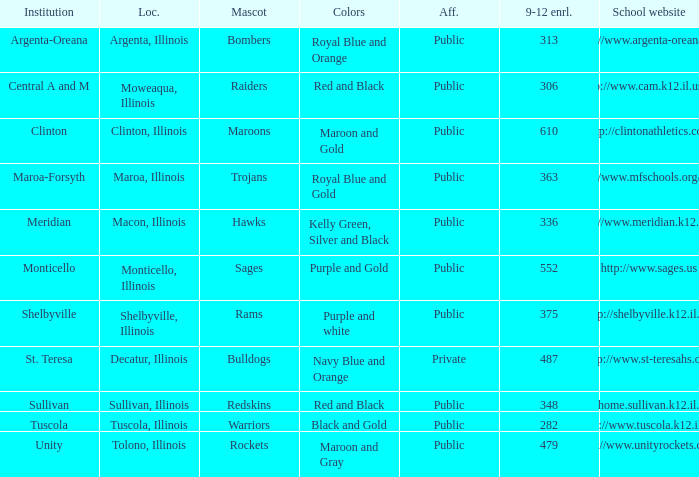How many different combinations of team colors are there in all the schools in Maroa, Illinois? 1.0. 